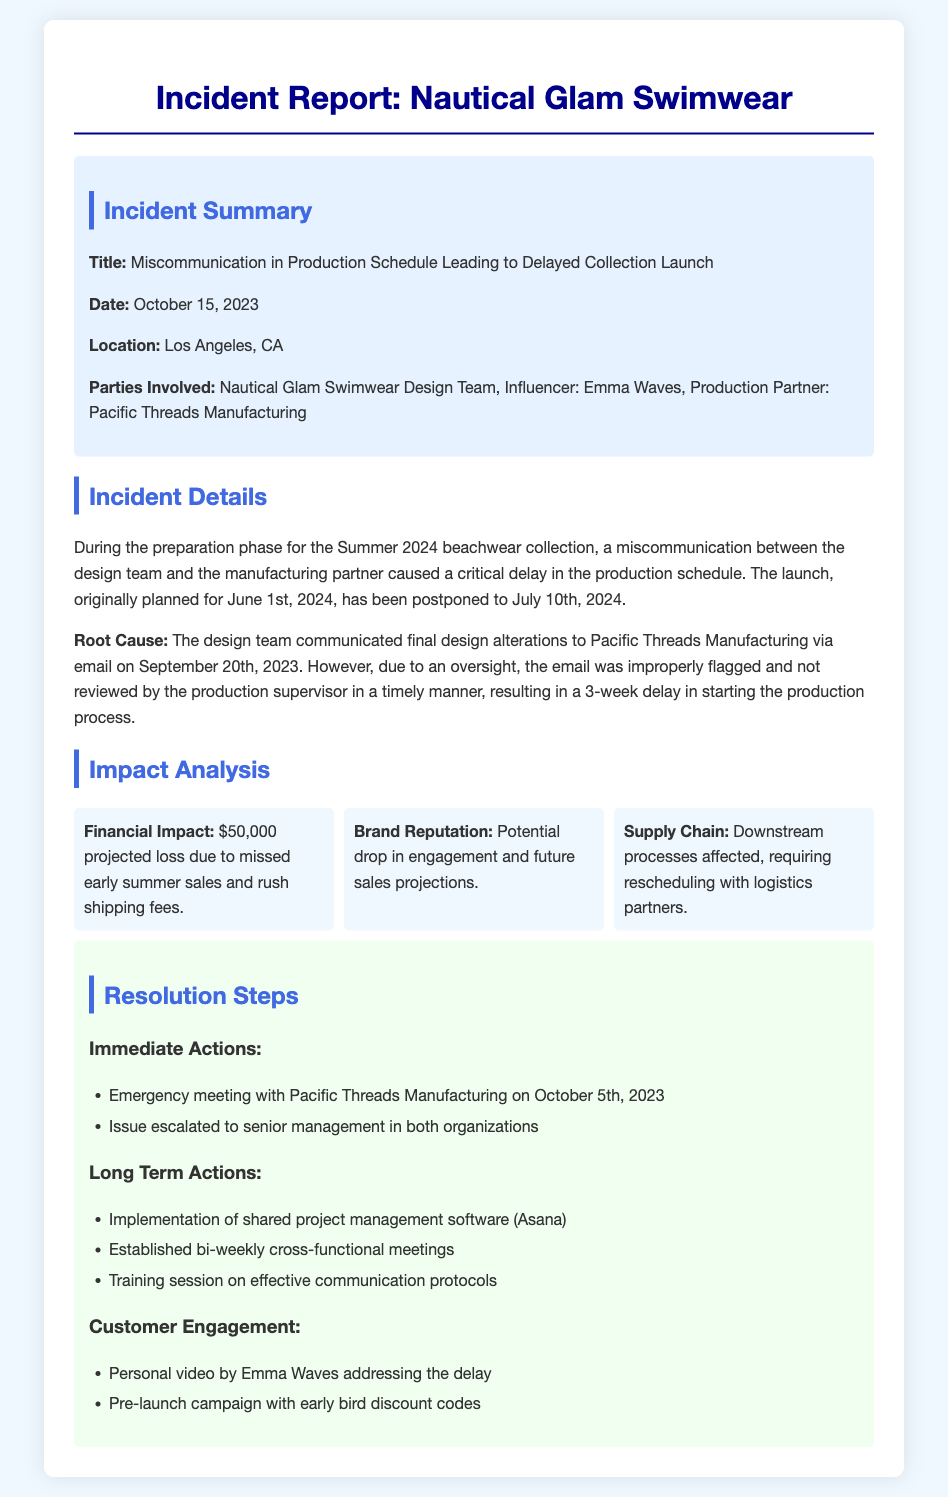What was the original launch date for the collection? The original launch date for the collection was June 1st, 2024.
Answer: June 1st, 2024 What is the title of the incident report? The title of the incident report is stated at the beginning of the document, indicating the nature of the incident.
Answer: Miscommunication in Production Schedule Leading to Delayed Collection Launch Who is the influencer involved in this incident? The document specifies the influencer involved in the incident as part of the parties involved.
Answer: Emma Waves What was the financial impact of the delay? The financial impact is outlined as a projected loss, providing specific monetary figures in the document.
Answer: $50,000 What is one long-term action proposed in the resolution steps? The long-term actions include various steps aimed at preventing future incidents, as detailed in the resolution section.
Answer: Implementation of shared project management software (Asana) How many weeks was the production delayed? The delay was described as a result of communication issues leading to a specific time frame mentioned in the document.
Answer: 3 weeks What date did the design team communicate final alterations? The document includes the date when the design team communicated alterations, pivotal to the incident.
Answer: September 20th, 2023 What customer engagement tactic is mentioned in the incident report? The report outlines specific tactics aimed at engaging customers during the delay, indicating efforts to maintain interest.
Answer: Personal video by Emma Waves addressing the delay What location is mentioned for the incident? The location of the incident is specified within the incident summary section of the report.
Answer: Los Angeles, CA 